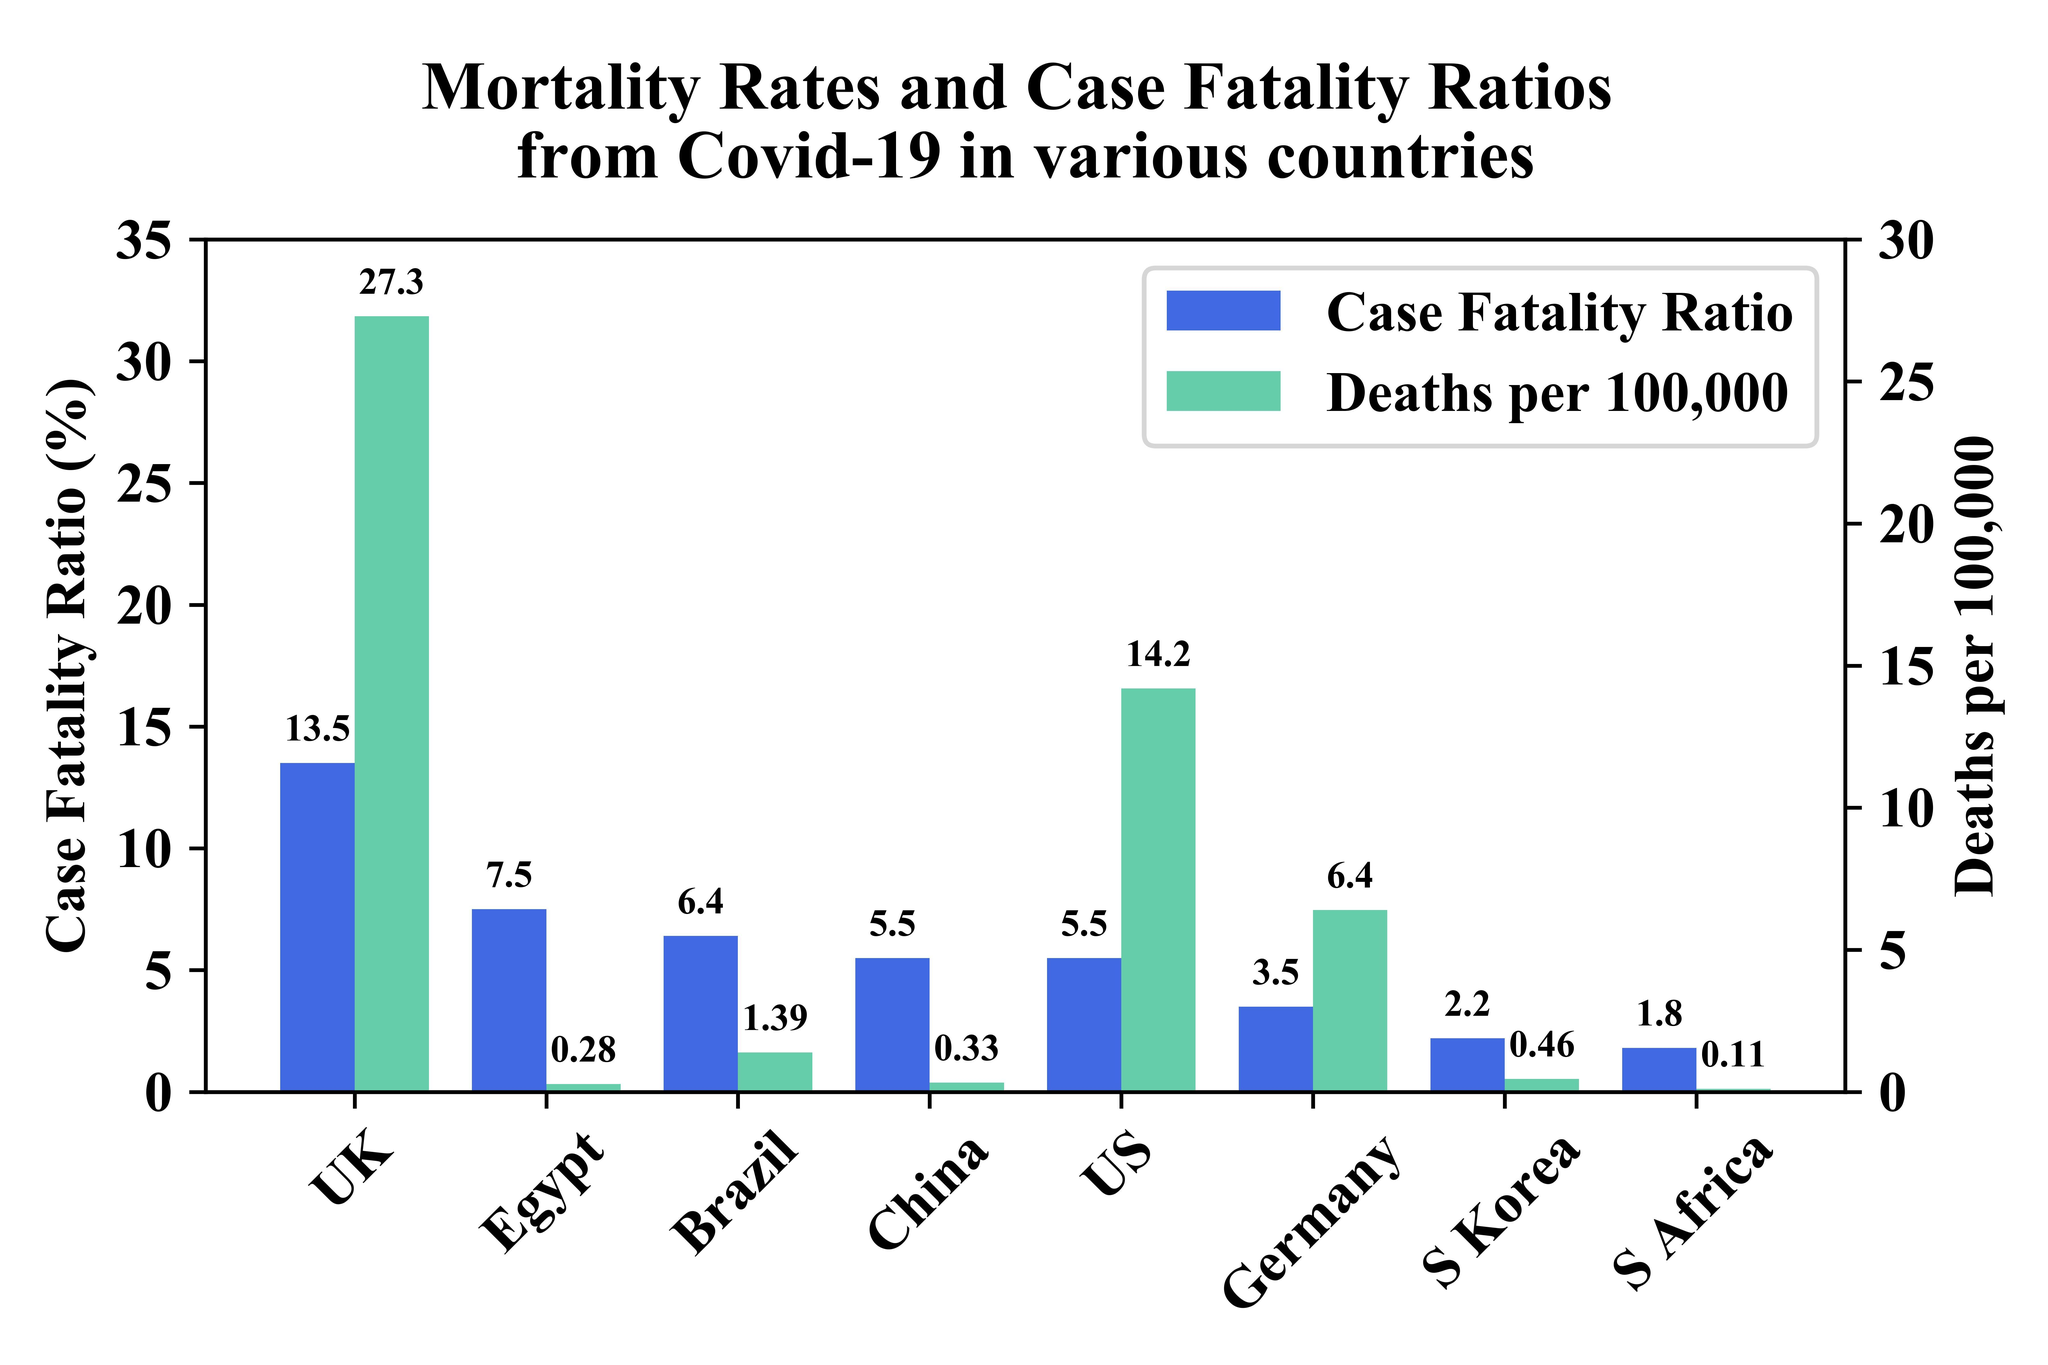What is the percentage of the case fatality ratio in the UK and the US, taken together?
Answer the question with a short phrase. 19% How many countries are in this graph? 8 What is the percentage of the case fatality ratio in Egypt and Brazil, taken together? 13.9% 